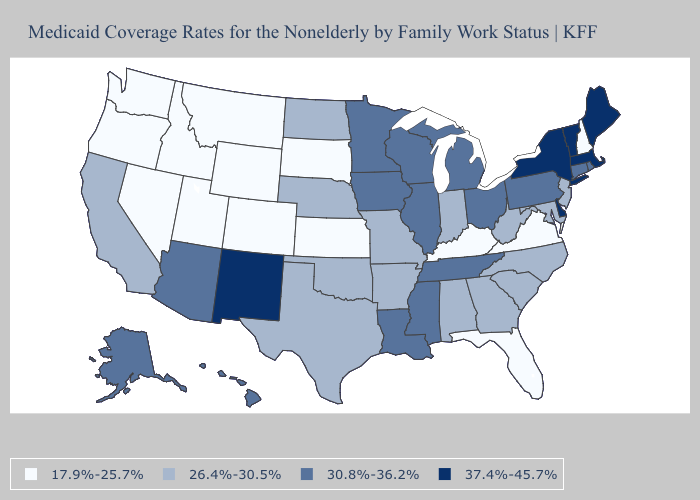Which states hav the highest value in the Northeast?
Be succinct. Maine, Massachusetts, New York, Vermont. Does North Dakota have the highest value in the USA?
Keep it brief. No. Name the states that have a value in the range 26.4%-30.5%?
Write a very short answer. Alabama, Arkansas, California, Georgia, Indiana, Maryland, Missouri, Nebraska, New Jersey, North Carolina, North Dakota, Oklahoma, South Carolina, Texas, West Virginia. Among the states that border Vermont , which have the highest value?
Write a very short answer. Massachusetts, New York. What is the lowest value in the Northeast?
Concise answer only. 17.9%-25.7%. Among the states that border Michigan , which have the lowest value?
Concise answer only. Indiana. What is the value of Wisconsin?
Give a very brief answer. 30.8%-36.2%. Name the states that have a value in the range 30.8%-36.2%?
Give a very brief answer. Alaska, Arizona, Connecticut, Hawaii, Illinois, Iowa, Louisiana, Michigan, Minnesota, Mississippi, Ohio, Pennsylvania, Rhode Island, Tennessee, Wisconsin. Among the states that border New York , which have the highest value?
Quick response, please. Massachusetts, Vermont. Does the first symbol in the legend represent the smallest category?
Give a very brief answer. Yes. Name the states that have a value in the range 26.4%-30.5%?
Quick response, please. Alabama, Arkansas, California, Georgia, Indiana, Maryland, Missouri, Nebraska, New Jersey, North Carolina, North Dakota, Oklahoma, South Carolina, Texas, West Virginia. Name the states that have a value in the range 26.4%-30.5%?
Give a very brief answer. Alabama, Arkansas, California, Georgia, Indiana, Maryland, Missouri, Nebraska, New Jersey, North Carolina, North Dakota, Oklahoma, South Carolina, Texas, West Virginia. Name the states that have a value in the range 37.4%-45.7%?
Be succinct. Delaware, Maine, Massachusetts, New Mexico, New York, Vermont. What is the value of Maryland?
Keep it brief. 26.4%-30.5%. What is the value of Arkansas?
Be succinct. 26.4%-30.5%. 